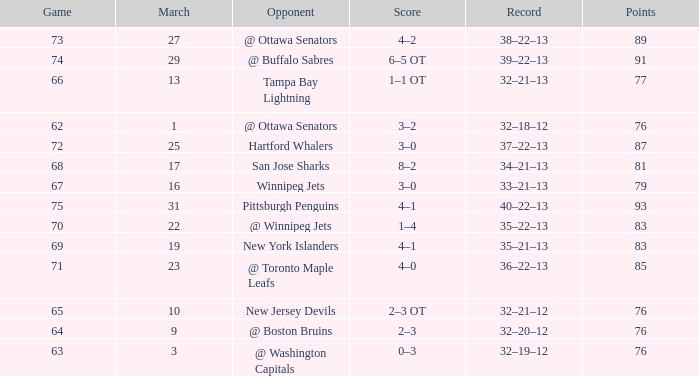How much March has Points of 85? 1.0. 